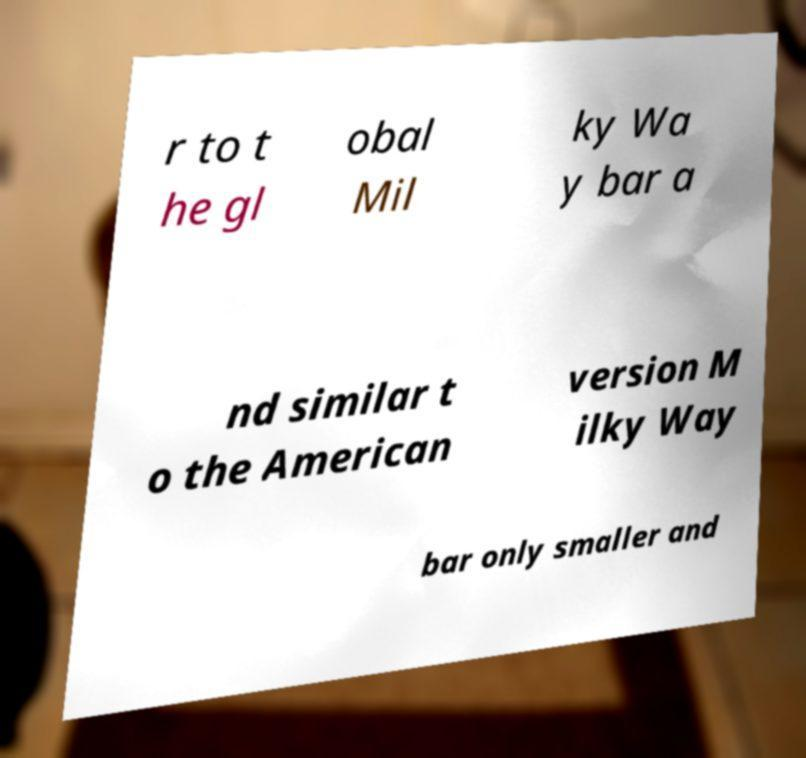Please identify and transcribe the text found in this image. r to t he gl obal Mil ky Wa y bar a nd similar t o the American version M ilky Way bar only smaller and 